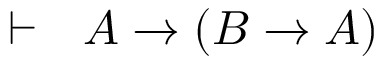<formula> <loc_0><loc_0><loc_500><loc_500>\vdash \ \ A \rightarrow \left ( B \rightarrow A \right )</formula> 